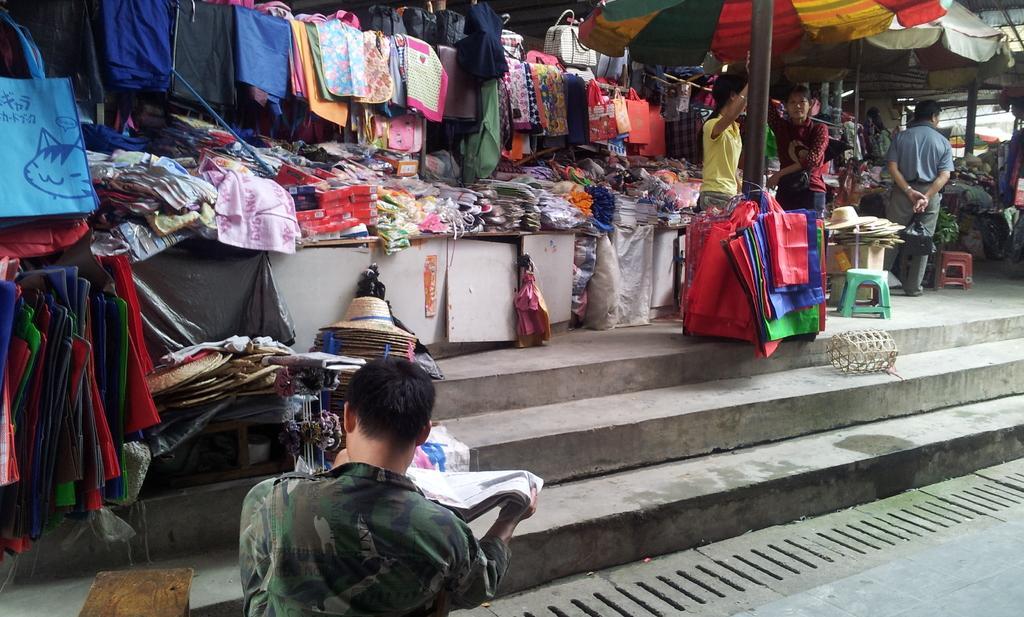Could you give a brief overview of what you see in this image? This picture describes about group of people, in the background we can find few bags, clothes and other things on the tables, also we can find few hats, chairs, vegetables and umbrellas. 